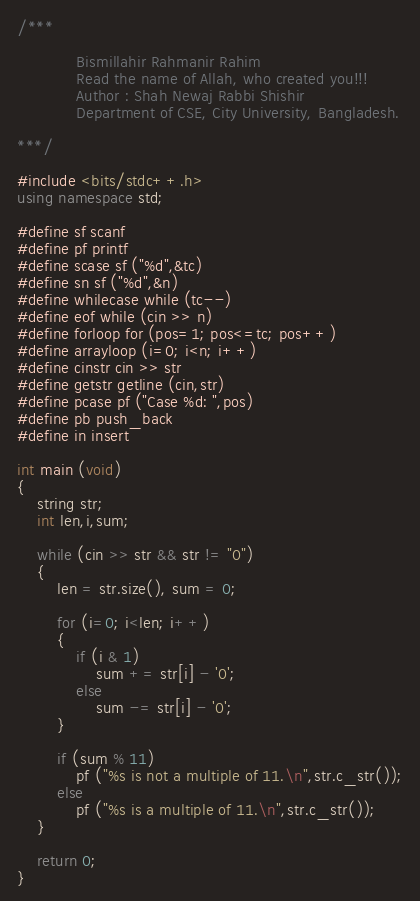Convert code to text. <code><loc_0><loc_0><loc_500><loc_500><_C++_>/***

            Bismillahir Rahmanir Rahim
            Read the name of Allah, who created you!!!
            Author : Shah Newaj Rabbi Shishir
            Department of CSE, City University, Bangladesh.

***/

#include <bits/stdc++.h>
using namespace std;

#define sf scanf
#define pf printf
#define scase sf ("%d",&tc)
#define sn sf ("%d",&n)
#define whilecase while (tc--)
#define eof while (cin >> n)
#define forloop for (pos=1; pos<=tc; pos++)
#define arrayloop (i=0; i<n; i++)
#define cinstr cin >> str
#define getstr getline (cin,str)
#define pcase pf ("Case %d: ",pos)
#define pb push_back
#define in insert

int main (void)
{
    string str;
    int len,i,sum;

    while (cin >> str && str != "0")
    {
        len = str.size(), sum = 0;

        for (i=0; i<len; i++)
        {
            if (i & 1)
                sum += str[i] - '0';
            else
                sum -= str[i] - '0';
        }

        if (sum % 11)
            pf ("%s is not a multiple of 11.\n",str.c_str());
        else
            pf ("%s is a multiple of 11.\n",str.c_str());
    }

    return 0;
}
</code> 